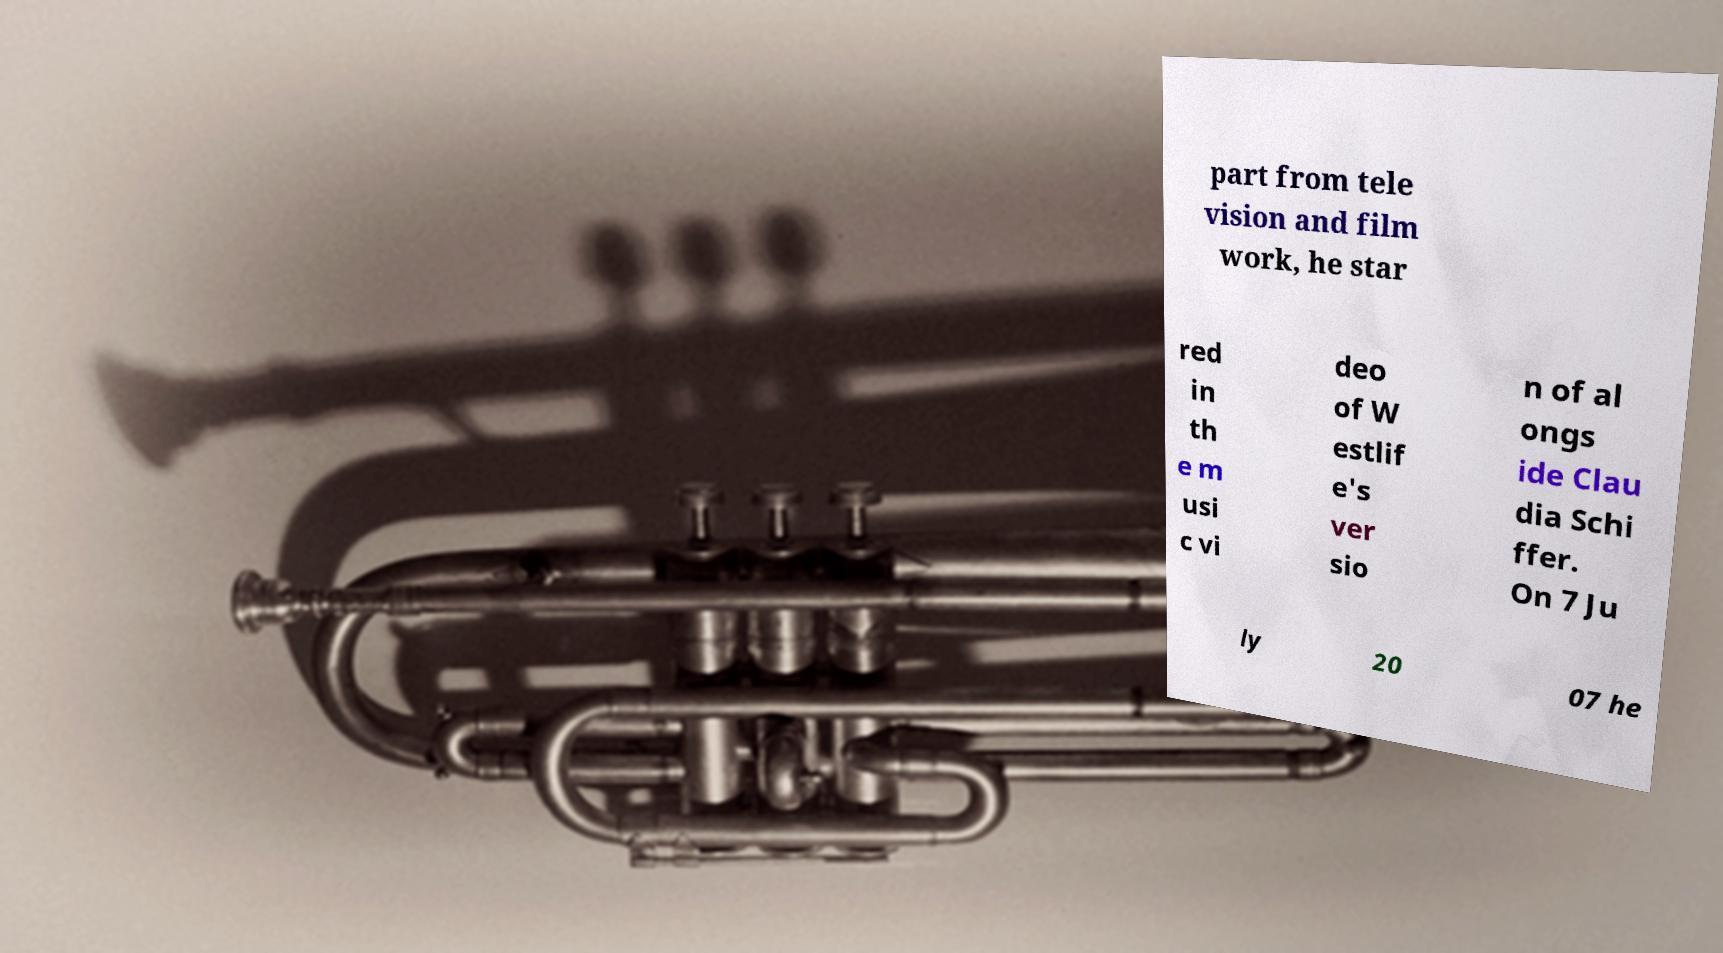Please identify and transcribe the text found in this image. part from tele vision and film work, he star red in th e m usi c vi deo of W estlif e's ver sio n of al ongs ide Clau dia Schi ffer. On 7 Ju ly 20 07 he 